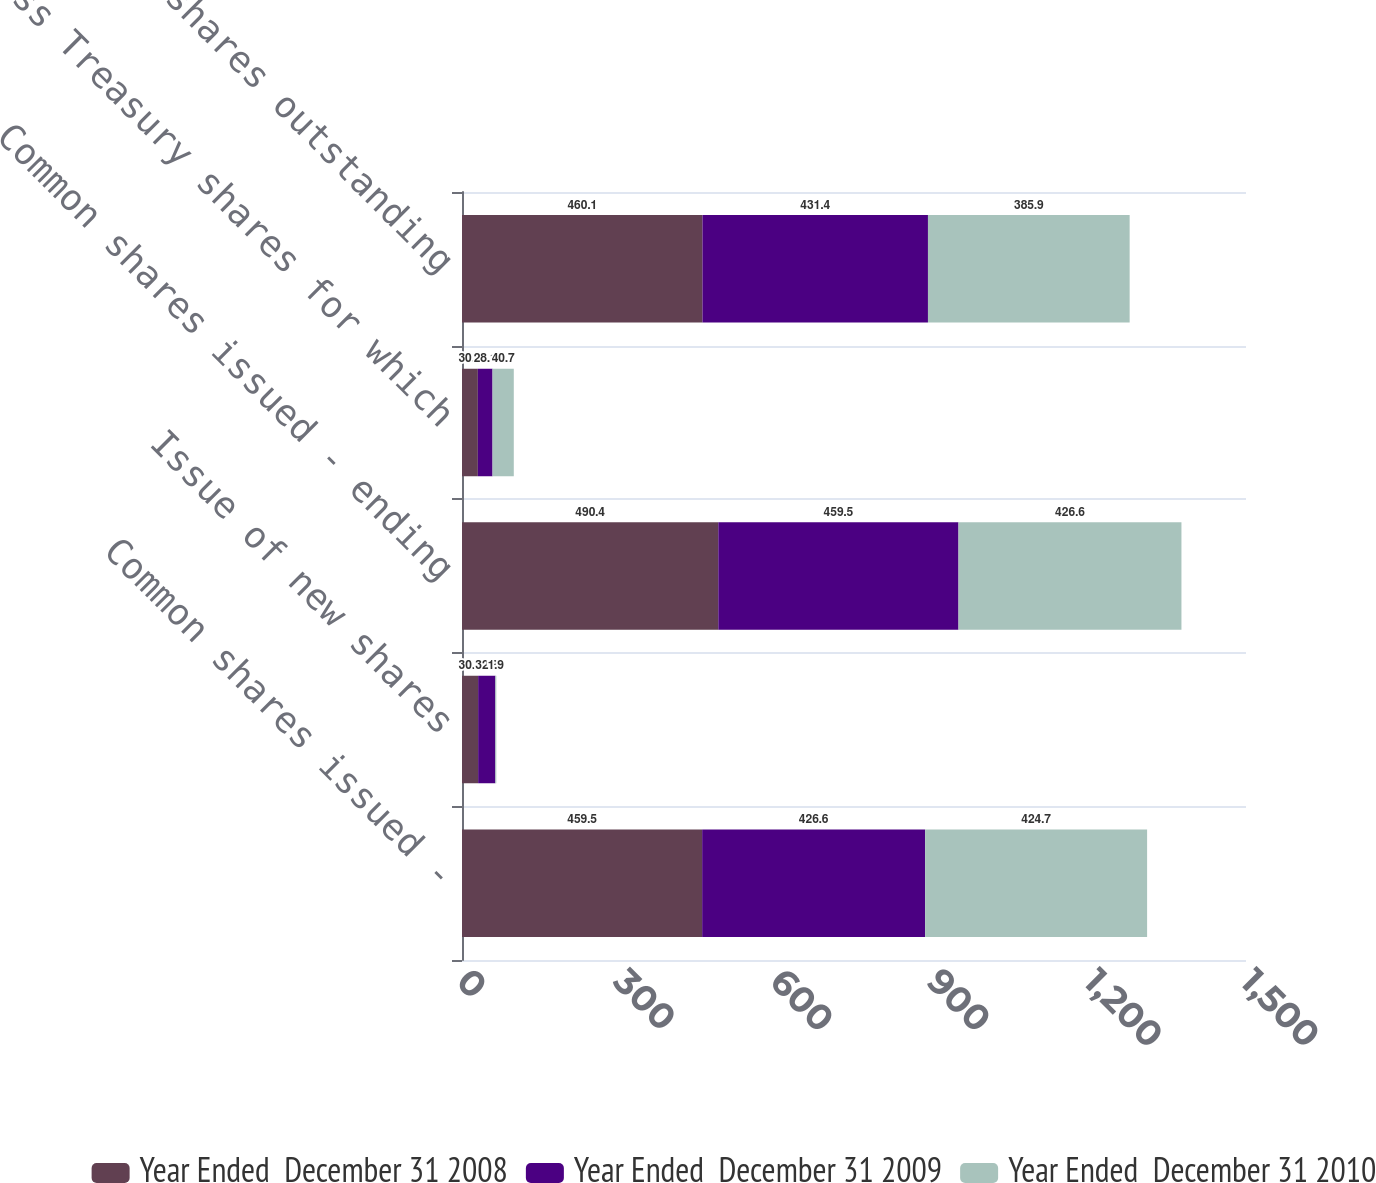<chart> <loc_0><loc_0><loc_500><loc_500><stacked_bar_chart><ecel><fcel>Common shares issued -<fcel>Issue of new shares<fcel>Common shares issued - ending<fcel>Less Treasury shares for which<fcel>Common shares outstanding<nl><fcel>Year Ended  December 31 2008<fcel>459.5<fcel>30.9<fcel>490.4<fcel>30.3<fcel>460.1<nl><fcel>Year Ended  December 31 2009<fcel>426.6<fcel>32.9<fcel>459.5<fcel>28.1<fcel>431.4<nl><fcel>Year Ended  December 31 2010<fcel>424.7<fcel>1.9<fcel>426.6<fcel>40.7<fcel>385.9<nl></chart> 